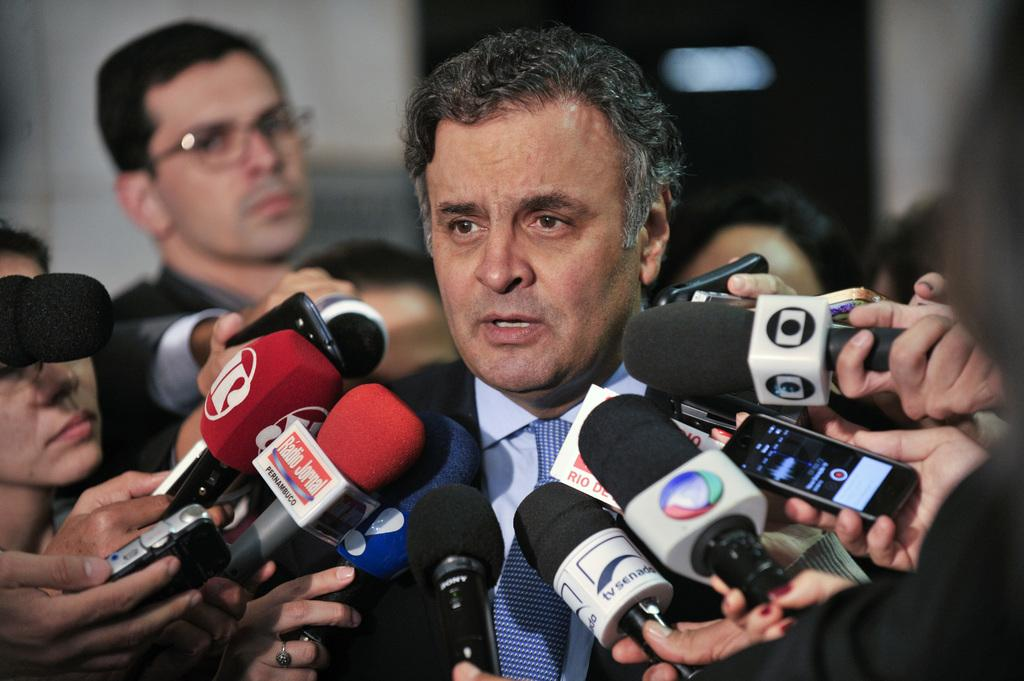What is the main subject of the image? There is a man standing in the middle of the image. Can you describe the people surrounding the man? The people are surrounding the man in the image. How does the man change the quiet atmosphere in the image? The image does not convey any information about the atmosphere being quiet, and the man's presence does not inherently change the atmosphere. 